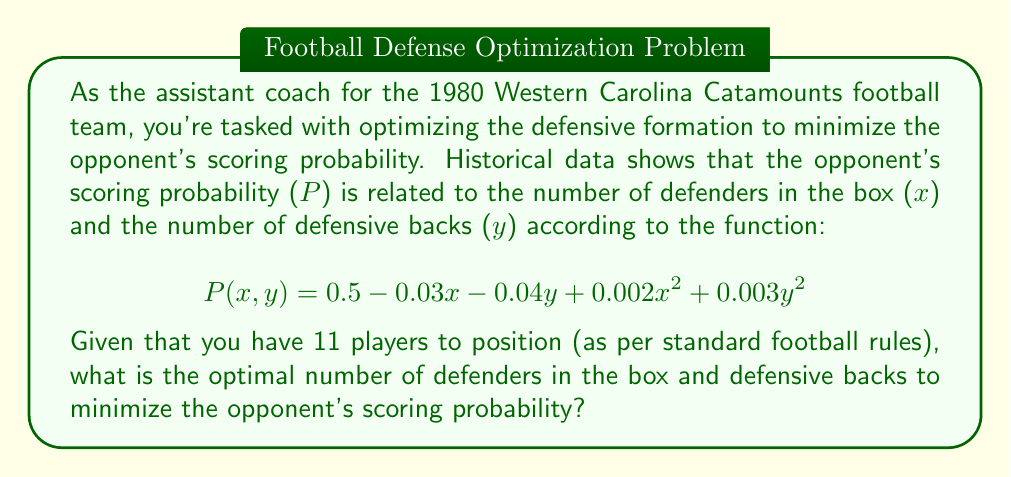Can you answer this question? To solve this optimization problem, we need to follow these steps:

1) First, we need to set up the constraint equation. Since we have 11 players in total:
   $$x + y = 11$$

2) We can substitute this into our probability function:
   $$P(x) = 0.5 - 0.03x - 0.04(11-x) + 0.002x^2 + 0.003(11-x)^2$$

3) Expand this equation:
   $$P(x) = 0.5 - 0.03x - 0.44 + 0.04x + 0.002x^2 + 0.003(121 - 22x + x^2)$$
   $$P(x) = 0.06 + 0.01x + 0.002x^2 + 0.363 - 0.066x + 0.003x^2$$
   $$P(x) = 0.423 - 0.056x + 0.005x^2$$

4) To find the minimum, we take the derivative and set it to zero:
   $$\frac{dP}{dx} = -0.056 + 0.01x = 0$$

5) Solve for x:
   $$0.01x = 0.056$$
   $$x = 5.6$$

6) Since we can't have fractional players, we need to check the integer values on either side:
   For x = 5: P(5) = 0.423 - 0.28 + 0.125 = 0.268
   For x = 6: P(6) = 0.423 - 0.336 + 0.18 = 0.267

7) Therefore, the optimal number of defenders in the box is 6.

8) The number of defensive backs is then: y = 11 - 6 = 5
Answer: The optimal defensive formation to minimize the opponent's scoring probability is 6 defenders in the box and 5 defensive backs. 